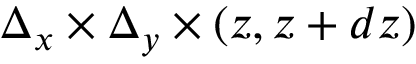<formula> <loc_0><loc_0><loc_500><loc_500>\Delta _ { x } \times \Delta _ { y } \times ( z , z + d z )</formula> 